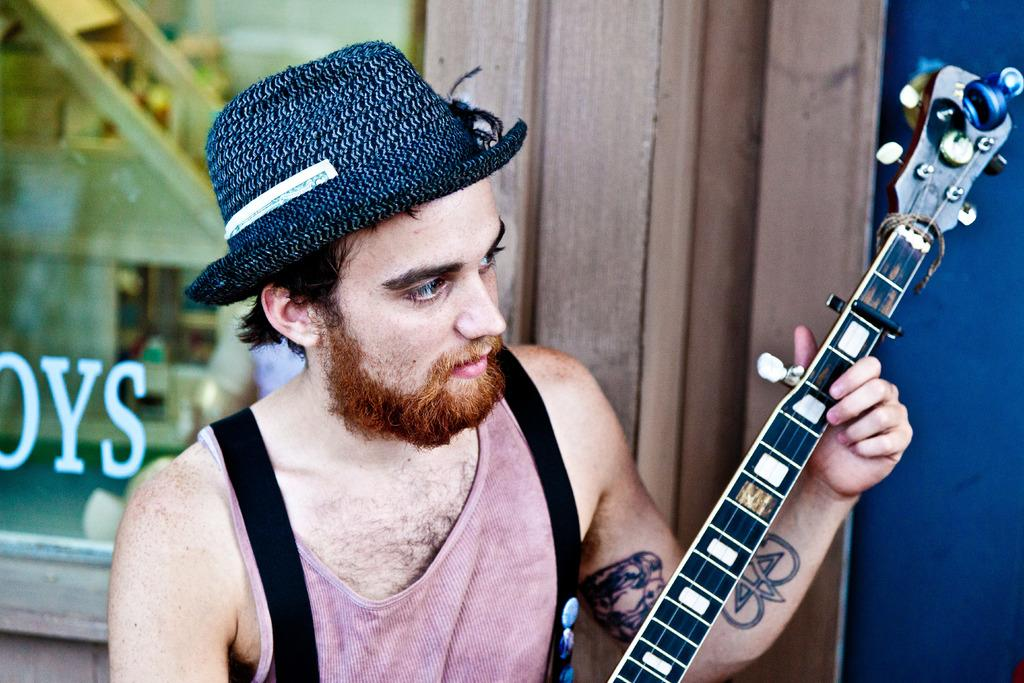What is the main subject of the image? The main subject of the image is a man. What is the man wearing in the image? The man is wearing a cap in the image. What object is the man holding in the image? The man is holding a guitar in the image. What can be seen in the background of the image? There is a glass window in the background of the image. What type of wood can be seen being adjusted by the man in the image? There is no wood or any adjustment activity present in the image. 